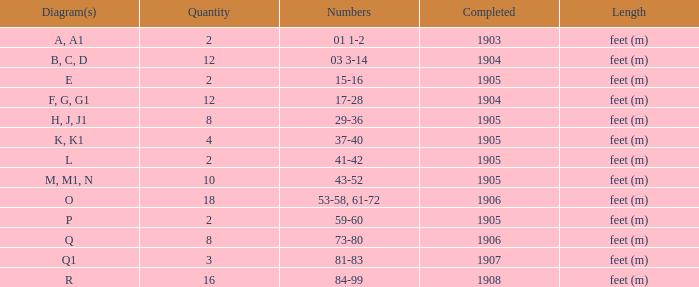Which is the lowest finished number in an item that has more than 10 and falls within the number ranges of 53-58 and 61-72? 1906.0. 